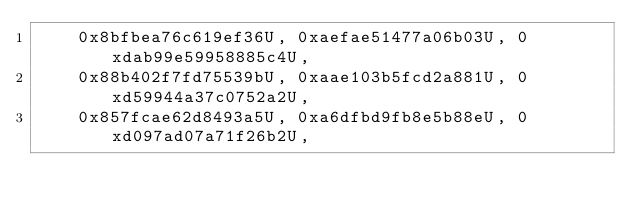Convert code to text. <code><loc_0><loc_0><loc_500><loc_500><_C++_>    0x8bfbea76c619ef36U, 0xaefae51477a06b03U, 0xdab99e59958885c4U,
    0x88b402f7fd75539bU, 0xaae103b5fcd2a881U, 0xd59944a37c0752a2U,
    0x857fcae62d8493a5U, 0xa6dfbd9fb8e5b88eU, 0xd097ad07a71f26b2U,</code> 